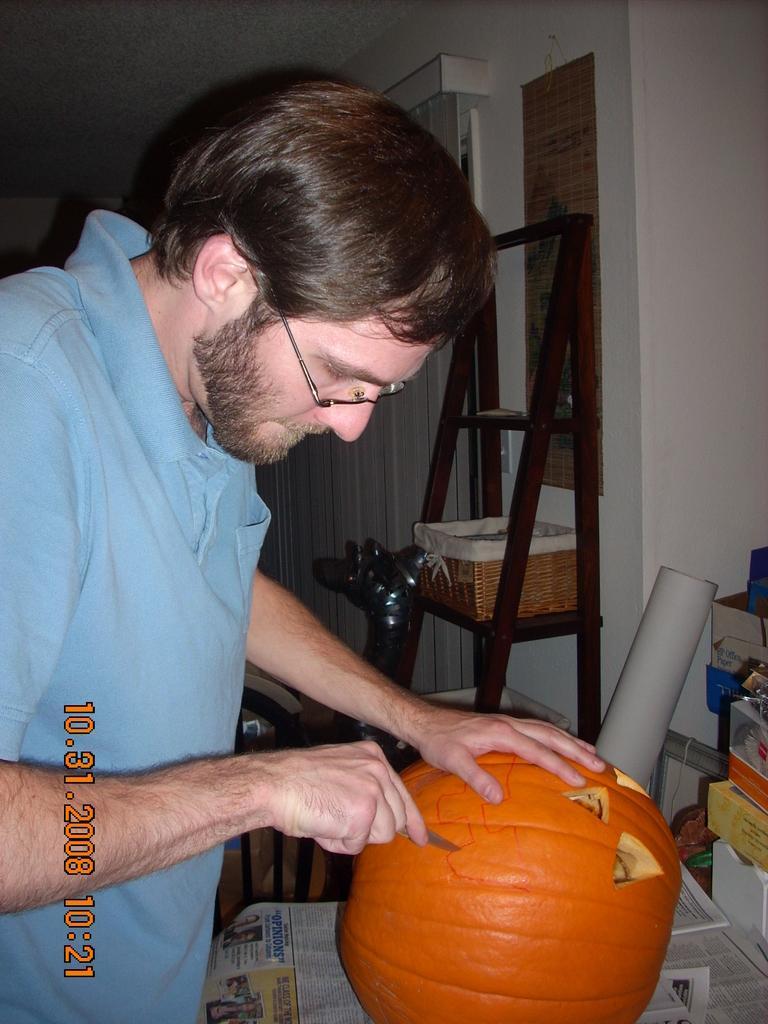In one or two sentences, can you explain what this image depicts? In this picture we can see a man wore spectacle and holding a knife with his hand and cutting a pumpkin placed on papers and in the background we can see a ladder, basket, curtain, wall. 